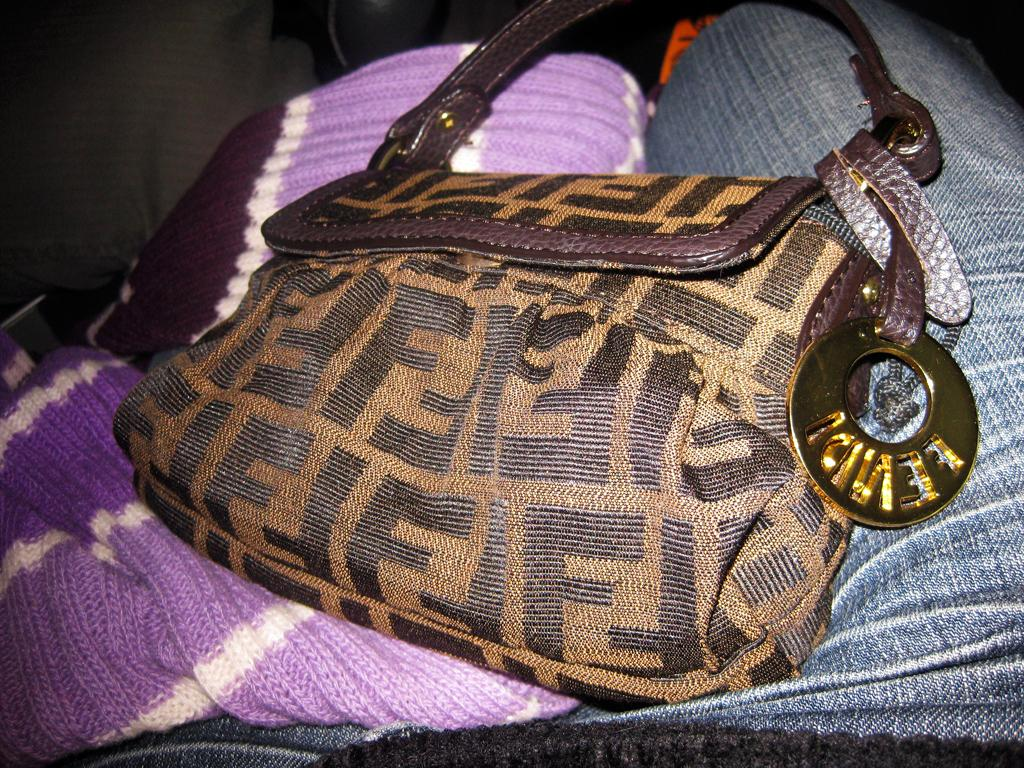What is the color of the bag in the image? The bag in the image is brown. What is the bag placed on? The bag is kept on some cloth. What accessory is attached to the bag? There is a locket on the bag. What is the purpose of the locket on the bag? The locket has a handle for the bag. How many eyes can be seen on the bag in the image? There are no eyes visible on the bag in the image. 